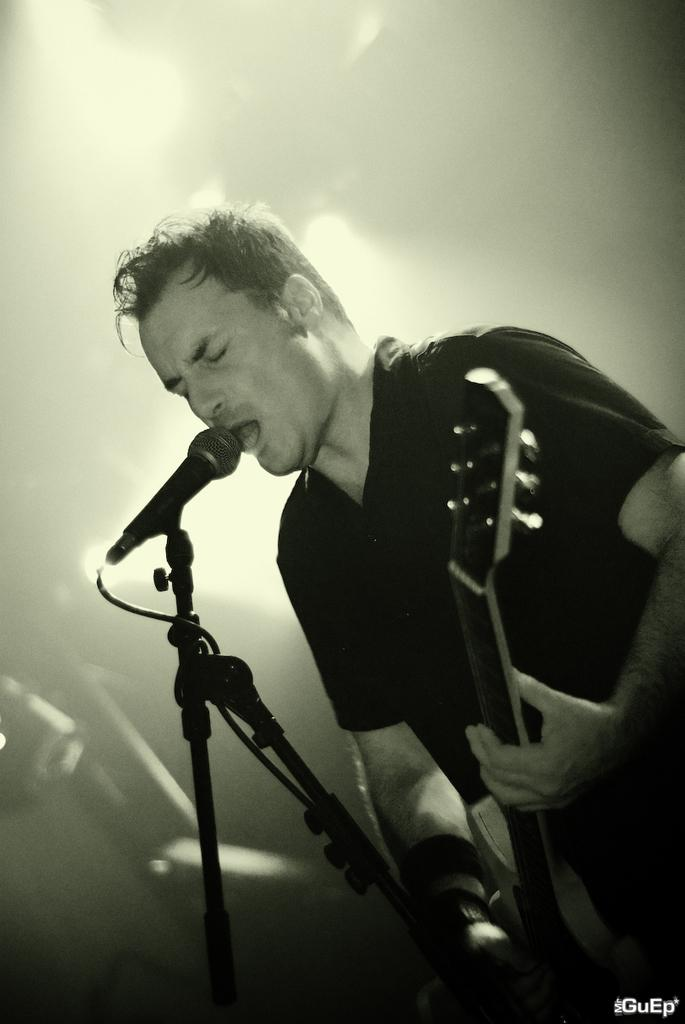What is the man in the image holding? The man is holding a guitar. What object is in front of the man? There is a microphone in front of the man. What type of clothing is the man wearing? The man is wearing a t-shirt. What type of pancake is the man flipping in the image? There is no pancake present in the image; the man is holding a guitar and standing near a microphone. 